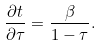<formula> <loc_0><loc_0><loc_500><loc_500>\frac { \partial t } { \partial \tau } = \frac { \beta } { 1 - \tau } .</formula> 